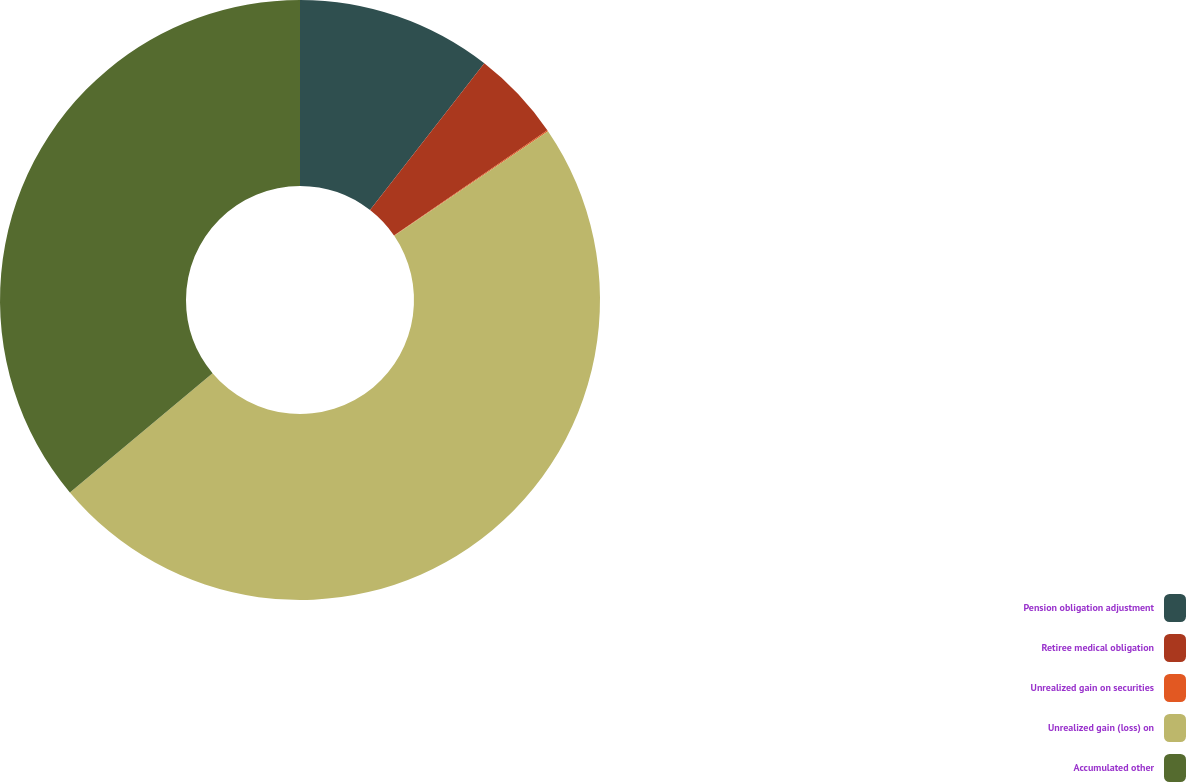Convert chart to OTSL. <chart><loc_0><loc_0><loc_500><loc_500><pie_chart><fcel>Pension obligation adjustment<fcel>Retiree medical obligation<fcel>Unrealized gain on securities<fcel>Unrealized gain (loss) on<fcel>Accumulated other<nl><fcel>10.53%<fcel>4.9%<fcel>0.06%<fcel>48.43%<fcel>36.09%<nl></chart> 